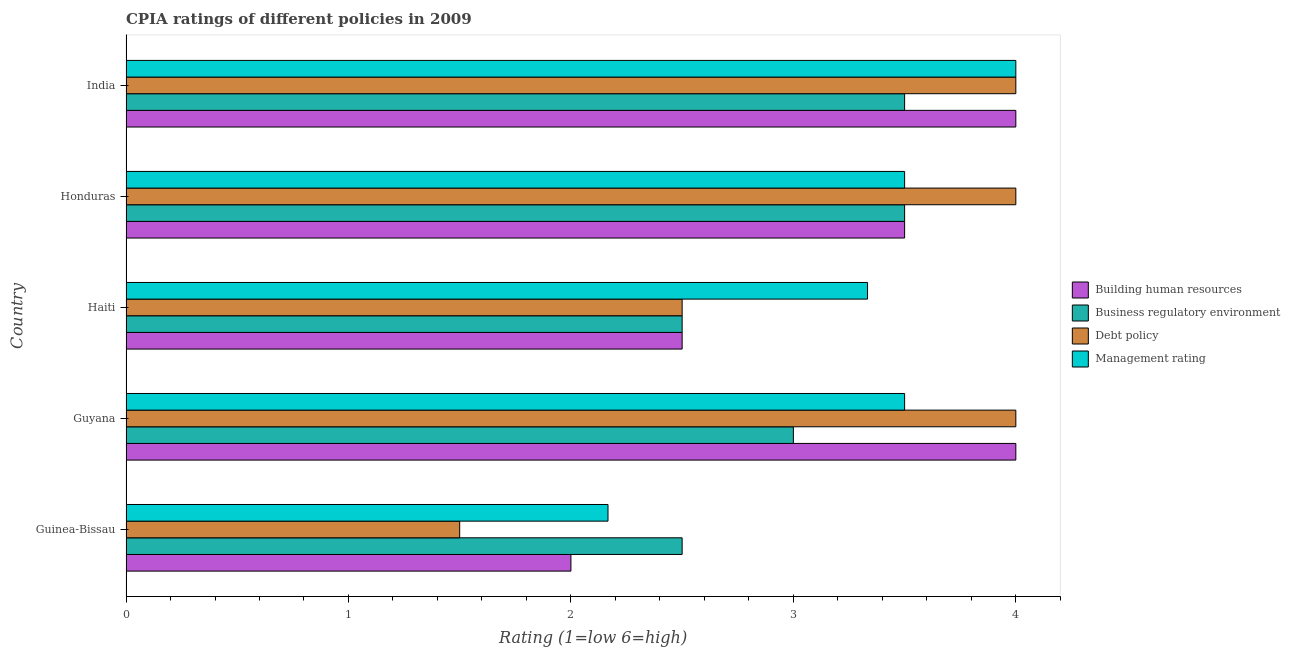How many different coloured bars are there?
Make the answer very short. 4. How many groups of bars are there?
Keep it short and to the point. 5. Are the number of bars per tick equal to the number of legend labels?
Give a very brief answer. Yes. Are the number of bars on each tick of the Y-axis equal?
Offer a very short reply. Yes. How many bars are there on the 5th tick from the bottom?
Your answer should be compact. 4. What is the label of the 5th group of bars from the top?
Offer a terse response. Guinea-Bissau. In how many cases, is the number of bars for a given country not equal to the number of legend labels?
Ensure brevity in your answer.  0. What is the cpia rating of management in Guyana?
Ensure brevity in your answer.  3.5. Across all countries, what is the maximum cpia rating of management?
Keep it short and to the point. 4. Across all countries, what is the minimum cpia rating of debt policy?
Keep it short and to the point. 1.5. In which country was the cpia rating of business regulatory environment maximum?
Your answer should be compact. Honduras. In which country was the cpia rating of building human resources minimum?
Keep it short and to the point. Guinea-Bissau. What is the total cpia rating of debt policy in the graph?
Your response must be concise. 16. What is the difference between the cpia rating of management in Honduras and the cpia rating of debt policy in Guinea-Bissau?
Your response must be concise. 2. What is the average cpia rating of business regulatory environment per country?
Keep it short and to the point. 3. What is the difference between the cpia rating of business regulatory environment and cpia rating of building human resources in Haiti?
Your response must be concise. 0. What is the ratio of the cpia rating of business regulatory environment in Guyana to that in Honduras?
Provide a short and direct response. 0.86. What is the difference between the highest and the second highest cpia rating of debt policy?
Keep it short and to the point. 0. In how many countries, is the cpia rating of management greater than the average cpia rating of management taken over all countries?
Your response must be concise. 4. Is the sum of the cpia rating of business regulatory environment in Haiti and India greater than the maximum cpia rating of management across all countries?
Keep it short and to the point. Yes. What does the 3rd bar from the top in Guyana represents?
Your response must be concise. Business regulatory environment. What does the 3rd bar from the bottom in India represents?
Make the answer very short. Debt policy. Is it the case that in every country, the sum of the cpia rating of building human resources and cpia rating of business regulatory environment is greater than the cpia rating of debt policy?
Provide a succinct answer. Yes. Are the values on the major ticks of X-axis written in scientific E-notation?
Your response must be concise. No. Does the graph contain grids?
Ensure brevity in your answer.  No. How many legend labels are there?
Provide a succinct answer. 4. How are the legend labels stacked?
Your answer should be compact. Vertical. What is the title of the graph?
Ensure brevity in your answer.  CPIA ratings of different policies in 2009. Does "Social Insurance" appear as one of the legend labels in the graph?
Offer a terse response. No. What is the label or title of the X-axis?
Offer a terse response. Rating (1=low 6=high). What is the Rating (1=low 6=high) in Building human resources in Guinea-Bissau?
Your answer should be compact. 2. What is the Rating (1=low 6=high) in Debt policy in Guinea-Bissau?
Provide a short and direct response. 1.5. What is the Rating (1=low 6=high) in Management rating in Guinea-Bissau?
Offer a very short reply. 2.17. What is the Rating (1=low 6=high) in Business regulatory environment in Haiti?
Ensure brevity in your answer.  2.5. What is the Rating (1=low 6=high) in Debt policy in Haiti?
Offer a very short reply. 2.5. What is the Rating (1=low 6=high) of Management rating in Haiti?
Your answer should be very brief. 3.33. What is the Rating (1=low 6=high) in Debt policy in Honduras?
Your response must be concise. 4. What is the Rating (1=low 6=high) of Management rating in Honduras?
Your response must be concise. 3.5. Across all countries, what is the maximum Rating (1=low 6=high) of Building human resources?
Offer a very short reply. 4. Across all countries, what is the maximum Rating (1=low 6=high) in Business regulatory environment?
Offer a terse response. 3.5. Across all countries, what is the maximum Rating (1=low 6=high) in Debt policy?
Give a very brief answer. 4. Across all countries, what is the maximum Rating (1=low 6=high) in Management rating?
Ensure brevity in your answer.  4. Across all countries, what is the minimum Rating (1=low 6=high) in Business regulatory environment?
Your answer should be compact. 2.5. Across all countries, what is the minimum Rating (1=low 6=high) in Debt policy?
Your response must be concise. 1.5. Across all countries, what is the minimum Rating (1=low 6=high) in Management rating?
Your answer should be very brief. 2.17. What is the difference between the Rating (1=low 6=high) of Building human resources in Guinea-Bissau and that in Guyana?
Ensure brevity in your answer.  -2. What is the difference between the Rating (1=low 6=high) in Management rating in Guinea-Bissau and that in Guyana?
Your response must be concise. -1.33. What is the difference between the Rating (1=low 6=high) of Building human resources in Guinea-Bissau and that in Haiti?
Your answer should be very brief. -0.5. What is the difference between the Rating (1=low 6=high) of Management rating in Guinea-Bissau and that in Haiti?
Keep it short and to the point. -1.17. What is the difference between the Rating (1=low 6=high) in Building human resources in Guinea-Bissau and that in Honduras?
Ensure brevity in your answer.  -1.5. What is the difference between the Rating (1=low 6=high) of Business regulatory environment in Guinea-Bissau and that in Honduras?
Your answer should be very brief. -1. What is the difference between the Rating (1=low 6=high) of Management rating in Guinea-Bissau and that in Honduras?
Your answer should be very brief. -1.33. What is the difference between the Rating (1=low 6=high) in Building human resources in Guinea-Bissau and that in India?
Offer a very short reply. -2. What is the difference between the Rating (1=low 6=high) of Debt policy in Guinea-Bissau and that in India?
Your answer should be compact. -2.5. What is the difference between the Rating (1=low 6=high) of Management rating in Guinea-Bissau and that in India?
Provide a short and direct response. -1.83. What is the difference between the Rating (1=low 6=high) of Debt policy in Guyana and that in Haiti?
Your response must be concise. 1.5. What is the difference between the Rating (1=low 6=high) in Management rating in Guyana and that in Haiti?
Provide a succinct answer. 0.17. What is the difference between the Rating (1=low 6=high) in Building human resources in Guyana and that in India?
Make the answer very short. 0. What is the difference between the Rating (1=low 6=high) in Debt policy in Guyana and that in India?
Offer a very short reply. 0. What is the difference between the Rating (1=low 6=high) in Building human resources in Haiti and that in Honduras?
Keep it short and to the point. -1. What is the difference between the Rating (1=low 6=high) of Debt policy in Haiti and that in Honduras?
Ensure brevity in your answer.  -1.5. What is the difference between the Rating (1=low 6=high) of Management rating in Haiti and that in Honduras?
Give a very brief answer. -0.17. What is the difference between the Rating (1=low 6=high) of Business regulatory environment in Haiti and that in India?
Keep it short and to the point. -1. What is the difference between the Rating (1=low 6=high) of Management rating in Haiti and that in India?
Offer a very short reply. -0.67. What is the difference between the Rating (1=low 6=high) of Building human resources in Honduras and that in India?
Provide a succinct answer. -0.5. What is the difference between the Rating (1=low 6=high) of Business regulatory environment in Honduras and that in India?
Offer a very short reply. 0. What is the difference between the Rating (1=low 6=high) of Building human resources in Guinea-Bissau and the Rating (1=low 6=high) of Business regulatory environment in Guyana?
Your answer should be compact. -1. What is the difference between the Rating (1=low 6=high) of Building human resources in Guinea-Bissau and the Rating (1=low 6=high) of Management rating in Guyana?
Provide a short and direct response. -1.5. What is the difference between the Rating (1=low 6=high) of Business regulatory environment in Guinea-Bissau and the Rating (1=low 6=high) of Debt policy in Guyana?
Provide a short and direct response. -1.5. What is the difference between the Rating (1=low 6=high) of Business regulatory environment in Guinea-Bissau and the Rating (1=low 6=high) of Management rating in Guyana?
Provide a short and direct response. -1. What is the difference between the Rating (1=low 6=high) of Building human resources in Guinea-Bissau and the Rating (1=low 6=high) of Business regulatory environment in Haiti?
Offer a very short reply. -0.5. What is the difference between the Rating (1=low 6=high) in Building human resources in Guinea-Bissau and the Rating (1=low 6=high) in Management rating in Haiti?
Offer a terse response. -1.33. What is the difference between the Rating (1=low 6=high) in Business regulatory environment in Guinea-Bissau and the Rating (1=low 6=high) in Debt policy in Haiti?
Offer a terse response. 0. What is the difference between the Rating (1=low 6=high) of Business regulatory environment in Guinea-Bissau and the Rating (1=low 6=high) of Management rating in Haiti?
Keep it short and to the point. -0.83. What is the difference between the Rating (1=low 6=high) in Debt policy in Guinea-Bissau and the Rating (1=low 6=high) in Management rating in Haiti?
Ensure brevity in your answer.  -1.83. What is the difference between the Rating (1=low 6=high) in Building human resources in Guinea-Bissau and the Rating (1=low 6=high) in Debt policy in Honduras?
Make the answer very short. -2. What is the difference between the Rating (1=low 6=high) in Debt policy in Guinea-Bissau and the Rating (1=low 6=high) in Management rating in Honduras?
Ensure brevity in your answer.  -2. What is the difference between the Rating (1=low 6=high) of Building human resources in Guinea-Bissau and the Rating (1=low 6=high) of Business regulatory environment in India?
Provide a short and direct response. -1.5. What is the difference between the Rating (1=low 6=high) of Building human resources in Guinea-Bissau and the Rating (1=low 6=high) of Debt policy in India?
Ensure brevity in your answer.  -2. What is the difference between the Rating (1=low 6=high) of Business regulatory environment in Guinea-Bissau and the Rating (1=low 6=high) of Debt policy in India?
Provide a succinct answer. -1.5. What is the difference between the Rating (1=low 6=high) in Business regulatory environment in Guinea-Bissau and the Rating (1=low 6=high) in Management rating in India?
Make the answer very short. -1.5. What is the difference between the Rating (1=low 6=high) in Debt policy in Guinea-Bissau and the Rating (1=low 6=high) in Management rating in India?
Give a very brief answer. -2.5. What is the difference between the Rating (1=low 6=high) in Business regulatory environment in Guyana and the Rating (1=low 6=high) in Debt policy in Haiti?
Offer a terse response. 0.5. What is the difference between the Rating (1=low 6=high) in Building human resources in Guyana and the Rating (1=low 6=high) in Business regulatory environment in Honduras?
Your response must be concise. 0.5. What is the difference between the Rating (1=low 6=high) in Building human resources in Guyana and the Rating (1=low 6=high) in Debt policy in Honduras?
Keep it short and to the point. 0. What is the difference between the Rating (1=low 6=high) in Building human resources in Guyana and the Rating (1=low 6=high) in Business regulatory environment in India?
Ensure brevity in your answer.  0.5. What is the difference between the Rating (1=low 6=high) of Business regulatory environment in Guyana and the Rating (1=low 6=high) of Debt policy in India?
Provide a short and direct response. -1. What is the difference between the Rating (1=low 6=high) of Building human resources in Haiti and the Rating (1=low 6=high) of Management rating in Honduras?
Ensure brevity in your answer.  -1. What is the difference between the Rating (1=low 6=high) of Business regulatory environment in Haiti and the Rating (1=low 6=high) of Management rating in Honduras?
Your answer should be compact. -1. What is the difference between the Rating (1=low 6=high) in Debt policy in Haiti and the Rating (1=low 6=high) in Management rating in Honduras?
Provide a short and direct response. -1. What is the difference between the Rating (1=low 6=high) of Business regulatory environment in Haiti and the Rating (1=low 6=high) of Debt policy in India?
Offer a terse response. -1.5. What is the difference between the Rating (1=low 6=high) in Business regulatory environment in Haiti and the Rating (1=low 6=high) in Management rating in India?
Provide a succinct answer. -1.5. What is the difference between the Rating (1=low 6=high) of Building human resources in Honduras and the Rating (1=low 6=high) of Debt policy in India?
Ensure brevity in your answer.  -0.5. What is the difference between the Rating (1=low 6=high) of Debt policy in Honduras and the Rating (1=low 6=high) of Management rating in India?
Offer a terse response. 0. What is the average Rating (1=low 6=high) in Building human resources per country?
Provide a short and direct response. 3.2. What is the average Rating (1=low 6=high) in Business regulatory environment per country?
Keep it short and to the point. 3. What is the average Rating (1=low 6=high) of Debt policy per country?
Offer a terse response. 3.2. What is the difference between the Rating (1=low 6=high) in Building human resources and Rating (1=low 6=high) in Management rating in Guinea-Bissau?
Provide a short and direct response. -0.17. What is the difference between the Rating (1=low 6=high) in Business regulatory environment and Rating (1=low 6=high) in Management rating in Guinea-Bissau?
Offer a very short reply. 0.33. What is the difference between the Rating (1=low 6=high) of Building human resources and Rating (1=low 6=high) of Debt policy in Guyana?
Your response must be concise. 0. What is the difference between the Rating (1=low 6=high) of Building human resources and Rating (1=low 6=high) of Management rating in Guyana?
Give a very brief answer. 0.5. What is the difference between the Rating (1=low 6=high) in Business regulatory environment and Rating (1=low 6=high) in Management rating in Guyana?
Your answer should be very brief. -0.5. What is the difference between the Rating (1=low 6=high) of Debt policy and Rating (1=low 6=high) of Management rating in Guyana?
Your response must be concise. 0.5. What is the difference between the Rating (1=low 6=high) of Building human resources and Rating (1=low 6=high) of Business regulatory environment in Haiti?
Keep it short and to the point. 0. What is the difference between the Rating (1=low 6=high) of Building human resources and Rating (1=low 6=high) of Debt policy in Haiti?
Offer a terse response. 0. What is the difference between the Rating (1=low 6=high) in Business regulatory environment and Rating (1=low 6=high) in Debt policy in Honduras?
Ensure brevity in your answer.  -0.5. What is the difference between the Rating (1=low 6=high) in Building human resources and Rating (1=low 6=high) in Business regulatory environment in India?
Your answer should be compact. 0.5. What is the difference between the Rating (1=low 6=high) of Business regulatory environment and Rating (1=low 6=high) of Debt policy in India?
Keep it short and to the point. -0.5. What is the difference between the Rating (1=low 6=high) in Debt policy and Rating (1=low 6=high) in Management rating in India?
Provide a succinct answer. 0. What is the ratio of the Rating (1=low 6=high) of Debt policy in Guinea-Bissau to that in Guyana?
Give a very brief answer. 0.38. What is the ratio of the Rating (1=low 6=high) in Management rating in Guinea-Bissau to that in Guyana?
Offer a terse response. 0.62. What is the ratio of the Rating (1=low 6=high) of Business regulatory environment in Guinea-Bissau to that in Haiti?
Provide a succinct answer. 1. What is the ratio of the Rating (1=low 6=high) of Debt policy in Guinea-Bissau to that in Haiti?
Provide a succinct answer. 0.6. What is the ratio of the Rating (1=low 6=high) of Management rating in Guinea-Bissau to that in Haiti?
Make the answer very short. 0.65. What is the ratio of the Rating (1=low 6=high) of Business regulatory environment in Guinea-Bissau to that in Honduras?
Your answer should be very brief. 0.71. What is the ratio of the Rating (1=low 6=high) of Management rating in Guinea-Bissau to that in Honduras?
Provide a short and direct response. 0.62. What is the ratio of the Rating (1=low 6=high) of Business regulatory environment in Guinea-Bissau to that in India?
Your answer should be very brief. 0.71. What is the ratio of the Rating (1=low 6=high) of Management rating in Guinea-Bissau to that in India?
Make the answer very short. 0.54. What is the ratio of the Rating (1=low 6=high) in Business regulatory environment in Guyana to that in Haiti?
Your response must be concise. 1.2. What is the ratio of the Rating (1=low 6=high) in Management rating in Guyana to that in Haiti?
Make the answer very short. 1.05. What is the ratio of the Rating (1=low 6=high) in Business regulatory environment in Guyana to that in Honduras?
Keep it short and to the point. 0.86. What is the ratio of the Rating (1=low 6=high) of Debt policy in Guyana to that in Honduras?
Ensure brevity in your answer.  1. What is the ratio of the Rating (1=low 6=high) of Management rating in Guyana to that in Honduras?
Provide a short and direct response. 1. What is the ratio of the Rating (1=low 6=high) in Building human resources in Haiti to that in Honduras?
Give a very brief answer. 0.71. What is the ratio of the Rating (1=low 6=high) of Debt policy in Haiti to that in Honduras?
Offer a very short reply. 0.62. What is the ratio of the Rating (1=low 6=high) of Management rating in Haiti to that in Honduras?
Your answer should be very brief. 0.95. What is the ratio of the Rating (1=low 6=high) of Building human resources in Haiti to that in India?
Offer a very short reply. 0.62. What is the ratio of the Rating (1=low 6=high) in Business regulatory environment in Haiti to that in India?
Provide a short and direct response. 0.71. What is the difference between the highest and the second highest Rating (1=low 6=high) in Building human resources?
Make the answer very short. 0. What is the difference between the highest and the second highest Rating (1=low 6=high) in Debt policy?
Keep it short and to the point. 0. What is the difference between the highest and the second highest Rating (1=low 6=high) in Management rating?
Give a very brief answer. 0.5. What is the difference between the highest and the lowest Rating (1=low 6=high) of Business regulatory environment?
Make the answer very short. 1. What is the difference between the highest and the lowest Rating (1=low 6=high) in Debt policy?
Give a very brief answer. 2.5. What is the difference between the highest and the lowest Rating (1=low 6=high) of Management rating?
Ensure brevity in your answer.  1.83. 